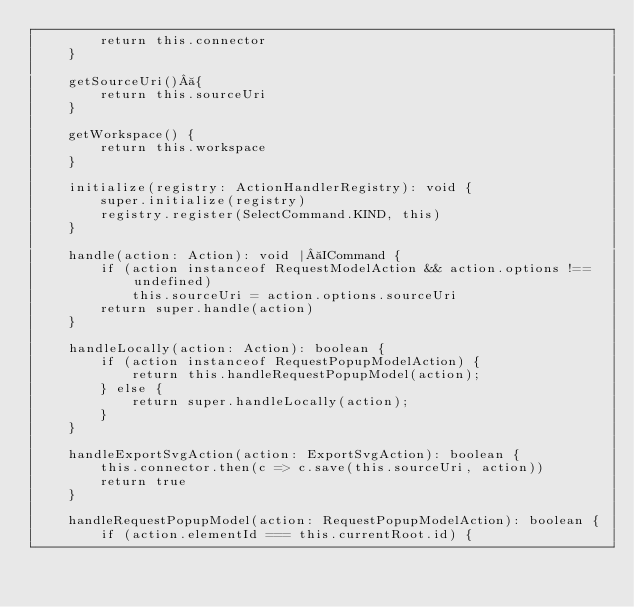Convert code to text. <code><loc_0><loc_0><loc_500><loc_500><_TypeScript_>        return this.connector
    }

    getSourceUri() {
        return this.sourceUri
    }

    getWorkspace() {
        return this.workspace
    }

    initialize(registry: ActionHandlerRegistry): void {
        super.initialize(registry)
        registry.register(SelectCommand.KIND, this)
    }

    handle(action: Action): void | ICommand {
        if (action instanceof RequestModelAction && action.options !== undefined)
            this.sourceUri = action.options.sourceUri
        return super.handle(action)
    }

    handleLocally(action: Action): boolean {
        if (action instanceof RequestPopupModelAction) {
            return this.handleRequestPopupModel(action);
        } else {
            return super.handleLocally(action);
        }
    }

    handleExportSvgAction(action: ExportSvgAction): boolean {
        this.connector.then(c => c.save(this.sourceUri, action))
        return true
    }

    handleRequestPopupModel(action: RequestPopupModelAction): boolean {
        if (action.elementId === this.currentRoot.id) {</code> 